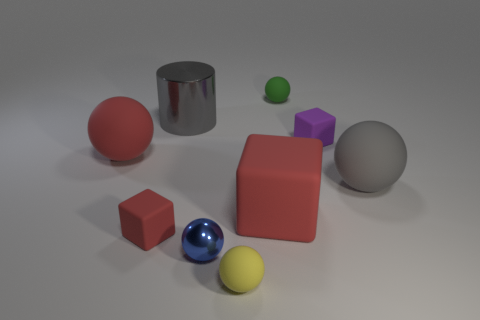Is the shape of the tiny purple rubber object the same as the small blue metallic thing?
Offer a very short reply. No. There is a red cube that is behind the matte block that is to the left of the large gray cylinder; is there a gray cylinder behind it?
Keep it short and to the point. Yes. How many other objects are the same color as the tiny metal thing?
Give a very brief answer. 0. There is a red matte block that is left of the metallic ball; is it the same size as the ball that is left of the metal sphere?
Ensure brevity in your answer.  No. Is the number of small rubber objects in front of the green matte thing the same as the number of balls behind the big gray rubber ball?
Provide a short and direct response. No. Are there any other things that are made of the same material as the purple thing?
Ensure brevity in your answer.  Yes. Do the blue ball and the red matte block that is right of the large gray cylinder have the same size?
Your answer should be very brief. No. There is a large ball that is on the right side of the big red matte object that is behind the big red matte block; what is it made of?
Your response must be concise. Rubber. Are there the same number of large gray spheres behind the big gray matte thing and small blue objects?
Ensure brevity in your answer.  No. What size is the object that is to the left of the small yellow matte object and in front of the small red matte block?
Keep it short and to the point. Small. 